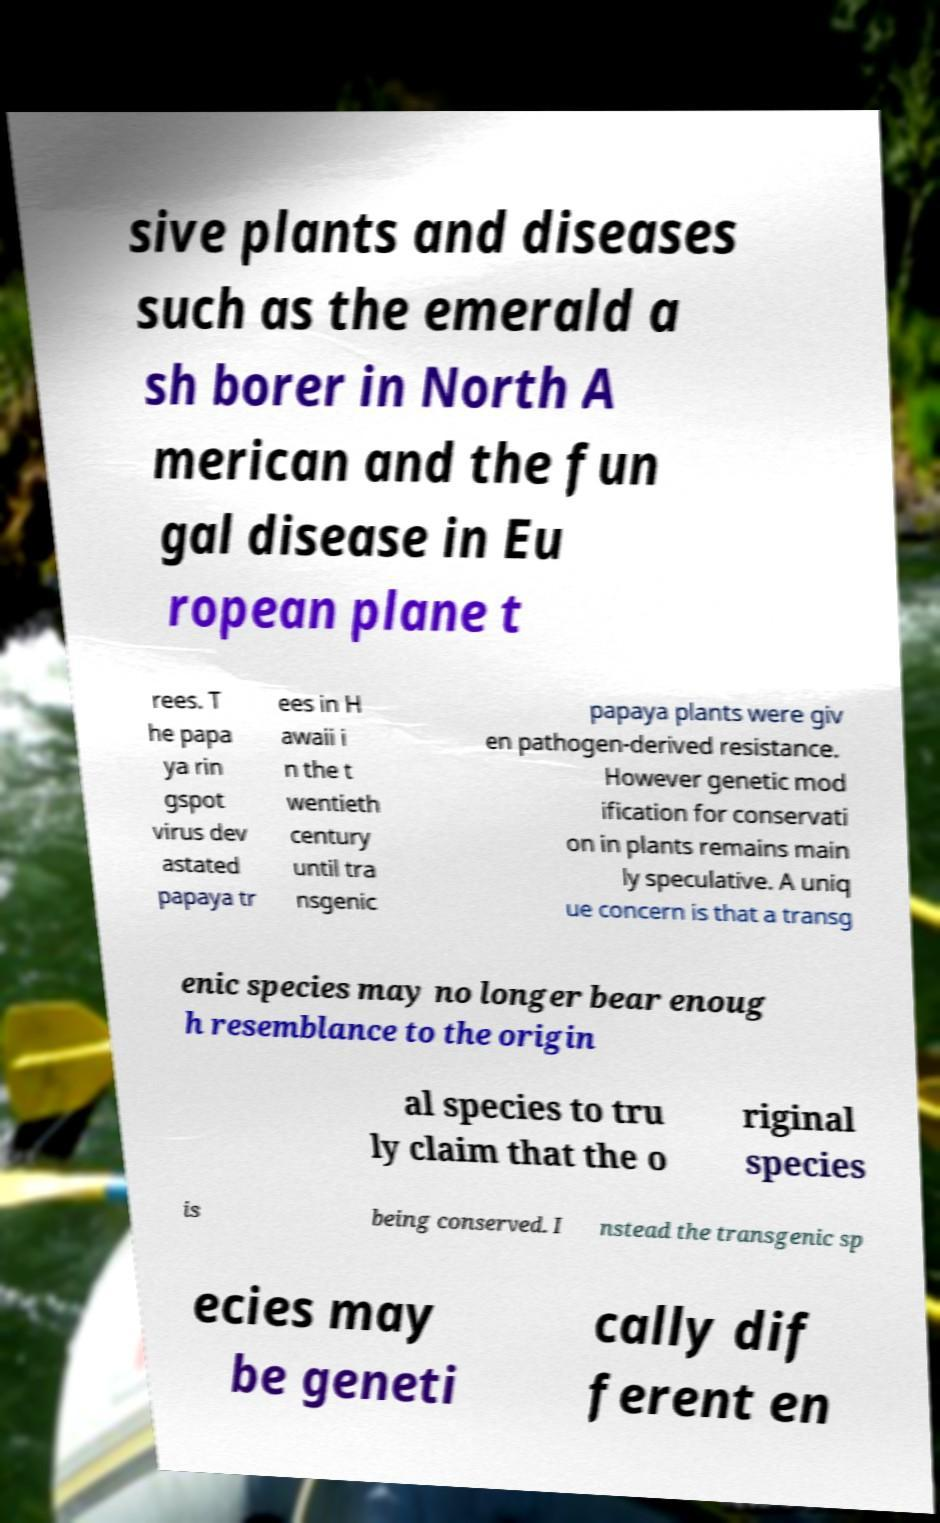Can you read and provide the text displayed in the image?This photo seems to have some interesting text. Can you extract and type it out for me? sive plants and diseases such as the emerald a sh borer in North A merican and the fun gal disease in Eu ropean plane t rees. T he papa ya rin gspot virus dev astated papaya tr ees in H awaii i n the t wentieth century until tra nsgenic papaya plants were giv en pathogen-derived resistance. However genetic mod ification for conservati on in plants remains main ly speculative. A uniq ue concern is that a transg enic species may no longer bear enoug h resemblance to the origin al species to tru ly claim that the o riginal species is being conserved. I nstead the transgenic sp ecies may be geneti cally dif ferent en 